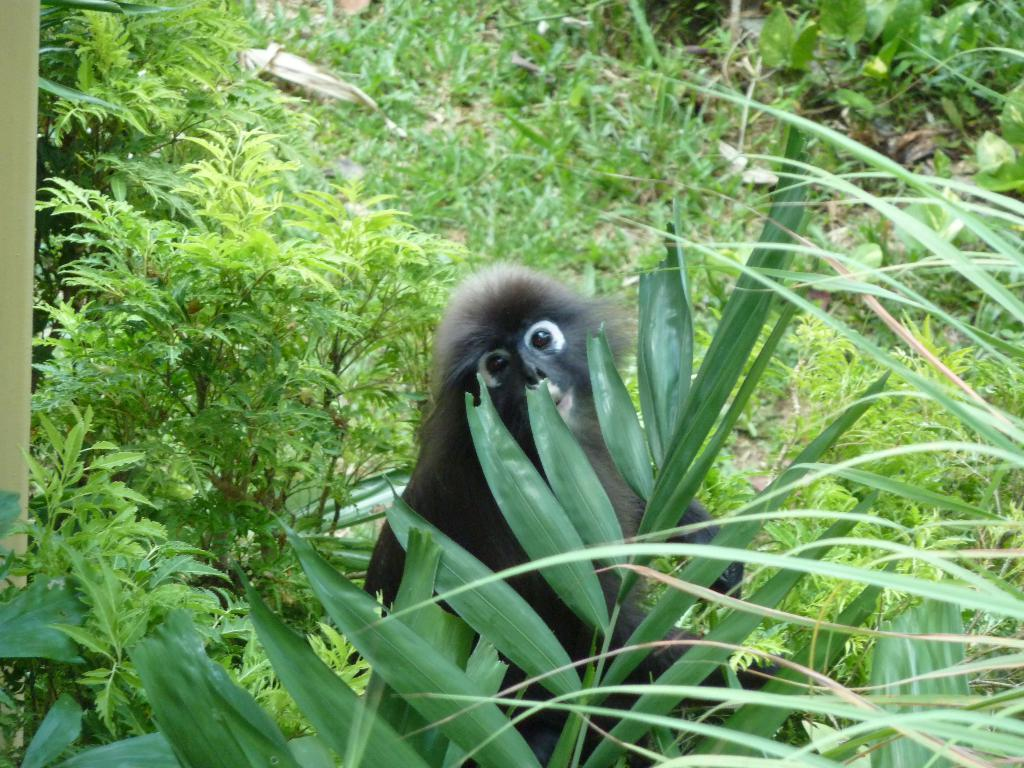What type of vegetation can be seen in the image? There are trees in the image. What is the color of the trees? The trees are green in color. What other living creature is present in the image? There is an animal in the image. What is the color of the animal? The animal is black in color. Where is the animal located in relation to the trees? The animal is located between the trees. What type of line can be seen connecting the trees in the image? There is no line connecting the trees in the image; it only shows trees and an animal. 